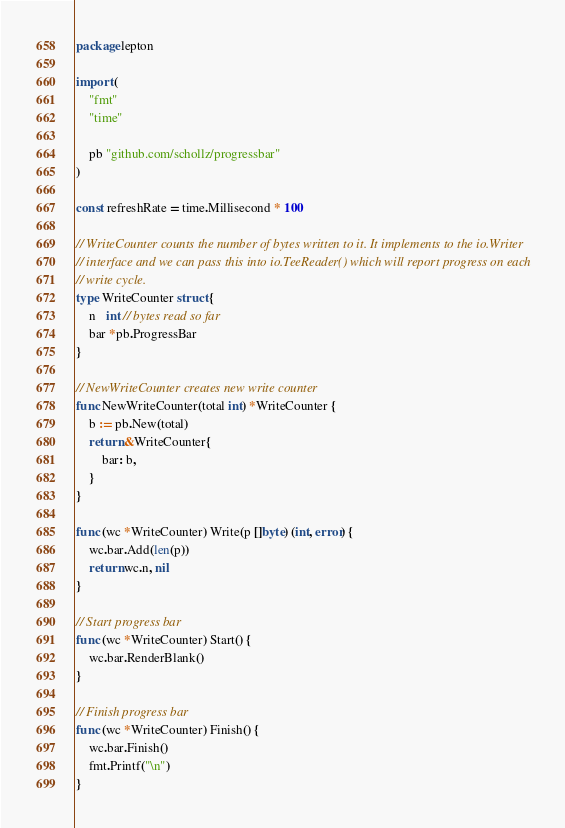<code> <loc_0><loc_0><loc_500><loc_500><_Go_>package lepton

import (
	"fmt"
	"time"

	pb "github.com/schollz/progressbar"
)

const refreshRate = time.Millisecond * 100

// WriteCounter counts the number of bytes written to it. It implements to the io.Writer
// interface and we can pass this into io.TeeReader() which will report progress on each
// write cycle.
type WriteCounter struct {
	n   int // bytes read so far
	bar *pb.ProgressBar
}

// NewWriteCounter creates new write counter
func NewWriteCounter(total int) *WriteCounter {
	b := pb.New(total)
	return &WriteCounter{
		bar: b,
	}
}

func (wc *WriteCounter) Write(p []byte) (int, error) {
	wc.bar.Add(len(p))
	return wc.n, nil
}

// Start progress bar
func (wc *WriteCounter) Start() {
	wc.bar.RenderBlank()
}

// Finish progress bar
func (wc *WriteCounter) Finish() {
	wc.bar.Finish()
	fmt.Printf("\n")
}
</code> 